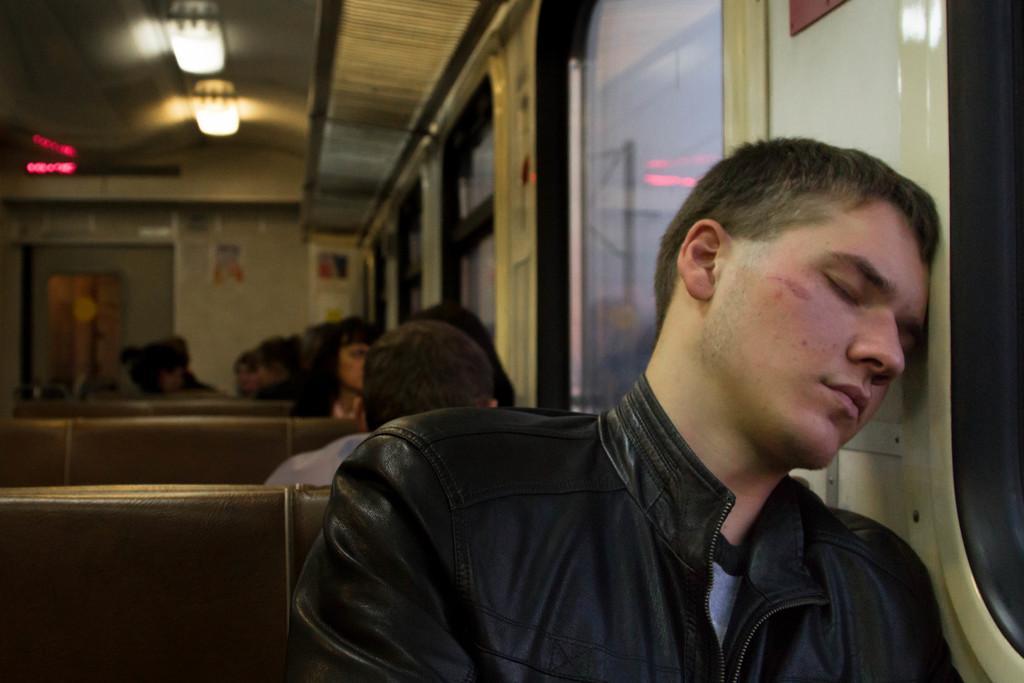Could you give a brief overview of what you see in this image? In front of the image there is a person sitting in the seat is sleeping by leaning his head onto the side wall of a train, behind him there are a few other people sitting on the seats, besides them there are glass windows, at the top there are lamps on the roof and there are sign boards. 